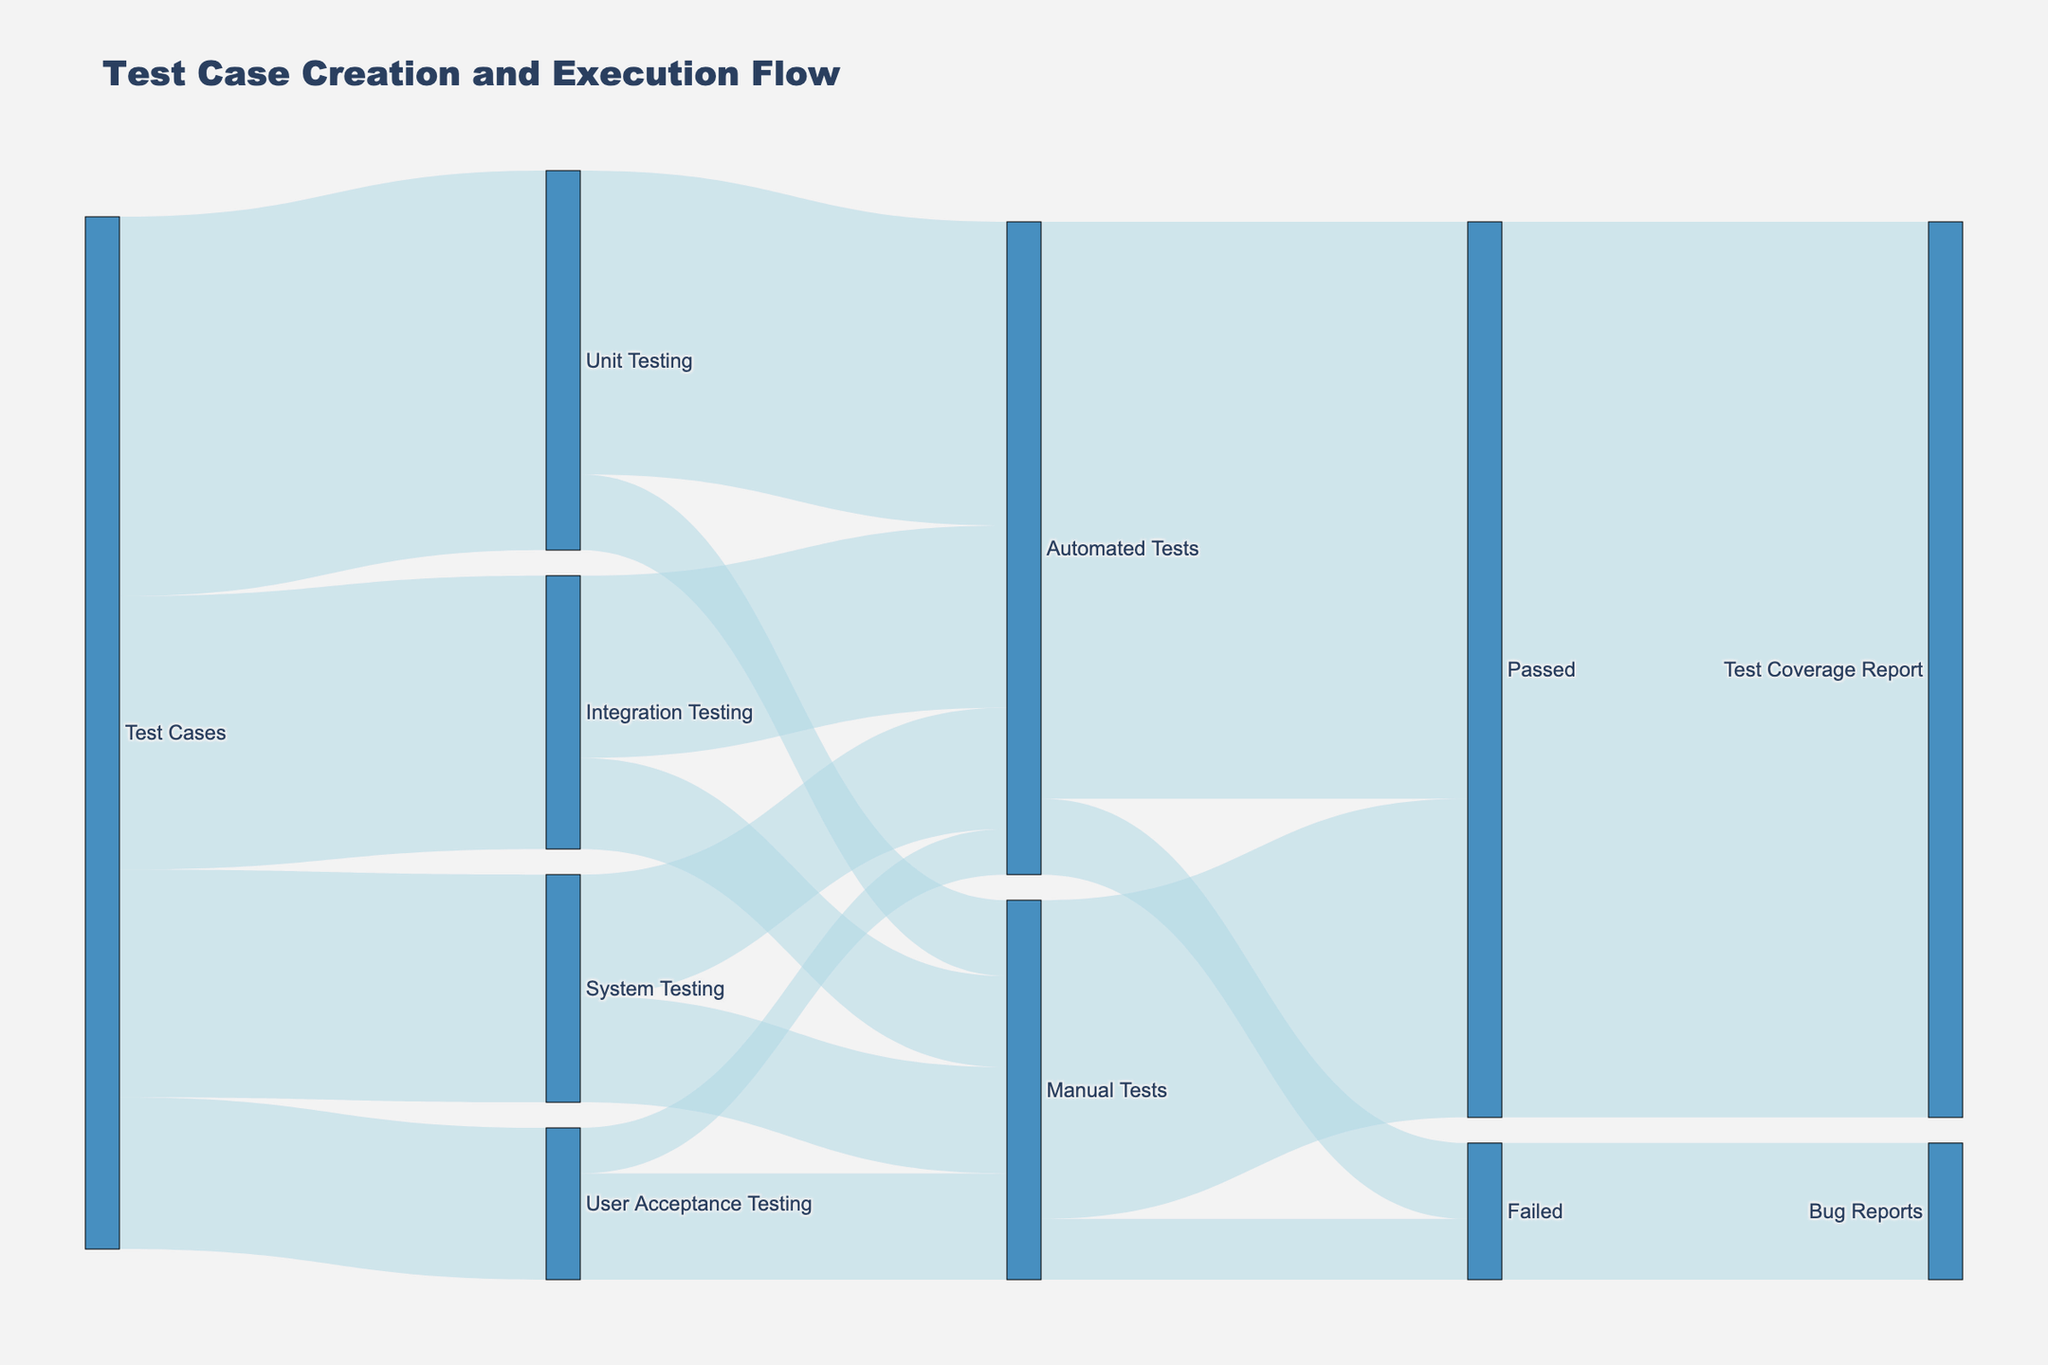What is the title of the Sankey Diagram? The title of the Sankey Diagram is located at the top of the figure.
Answer: Test Case Creation and Execution Flow How many test cases are being executed in total? To find the total number of test cases executed, sum up the values flowing out from "Test Cases": 250 (Unit) + 180 (Integration) + 150 (System) + 100 (User Acceptance) = 680.
Answer: 680 Which testing type has the highest number of automated tests? Check the connections from each testing type to "Automated Tests" and compare the amounts: Unit Testing (200), Integration Testing (120), System Testing (80), User Acceptance Testing (30). The highest number is 200 from Unit Testing.
Answer: Unit Testing What is the ratio of automated tests that passed to those that failed? Look at the values flowing out from "Automated Tests": Passed (380) and Failed (50). The ratio is calculated as 380 / 50 = 7.6.
Answer: 7.6 How many manual tests passed out of the total manual tests executed? To find this, add the values for manual tests that passed: 210 against the total manual tests (Unit Testing + Integration Testing + System Testing + User Acceptance Testing): 50 + 60 + 70 + 70 = 250. Therefore, 210 out of 250 manual tests passed.
Answer: 210 How many bug reports were generated from failed tests? Look at the flow from "Failed" to "Bug Reports" which is directly indicated by the Sankey Diagram.
Answer: 90 Compare the total number of failed automated tests to failed manual tests. Which is higher? Identify the values for failed tests: Automated Tests (50) vs. Manual Tests (40). Automated failed tests are higher.
Answer: Automated Tests Which area has the highest value flow in the entire diagram? The area with the highest value flow is the connection from "Automated Tests" to "Passed" with a value of 380.
Answer: Automated Tests to Passed What percentage of User Acceptance Testing is automated? First, look at User Acceptance Testing’s automated tests: 30. The total for User Acceptance Testing is: 30 (Automated) + 70 (Manual) = 100. The percentage is calculated as (30 / 100) * 100 = 30%.
Answer: 30% Which testing type has the lowest number of manual tests executed? Compare the manual testing values among all testing types: Unit Testing (50), Integration Testing (60), System Testing (70), User Acceptance Testing (70). The lowest number is for Unit Testing.
Answer: Unit Testing 